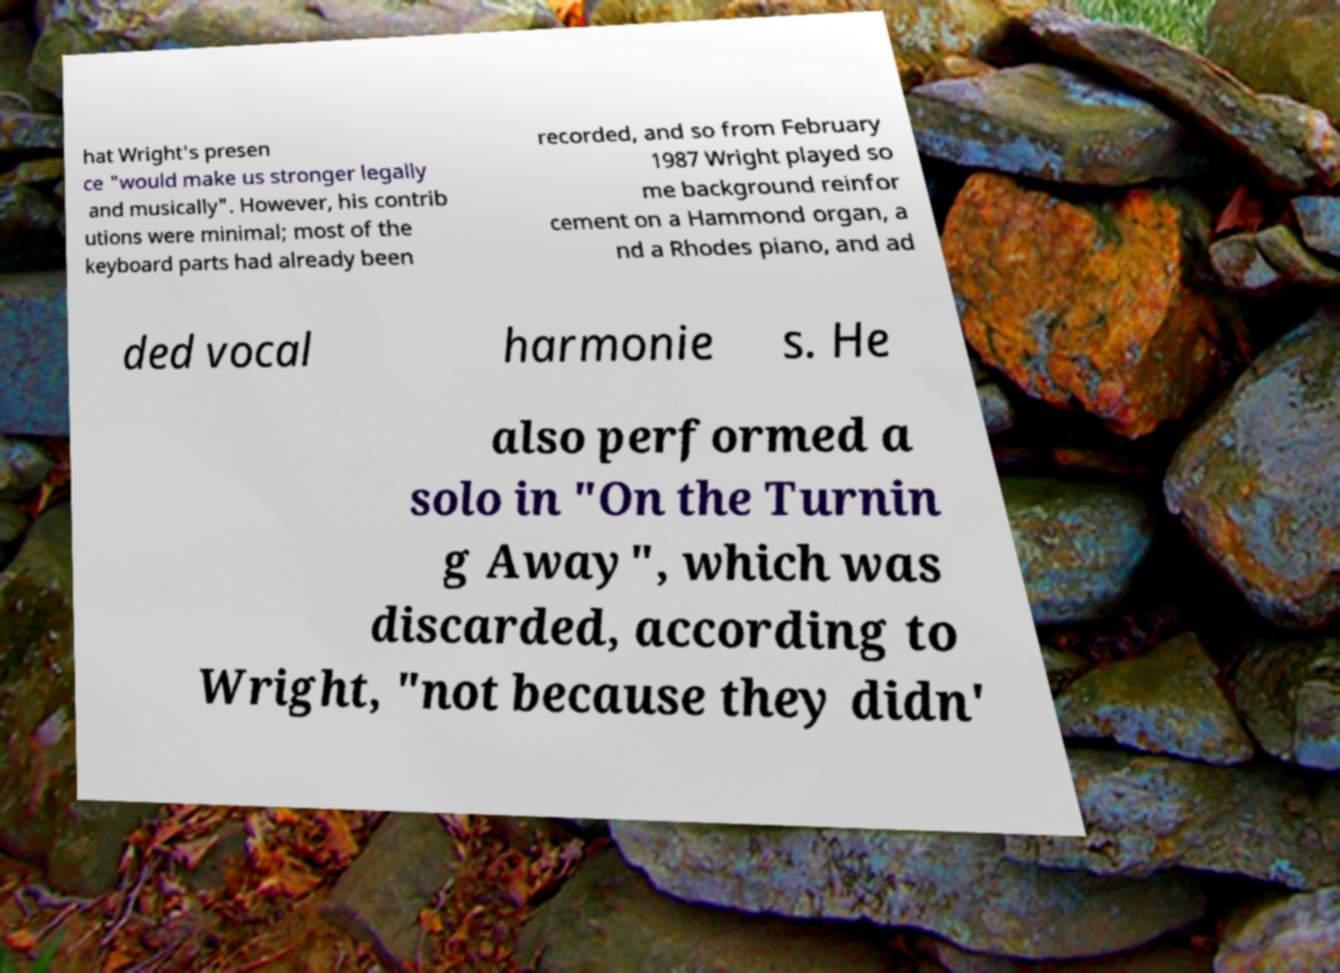For documentation purposes, I need the text within this image transcribed. Could you provide that? hat Wright's presen ce "would make us stronger legally and musically". However, his contrib utions were minimal; most of the keyboard parts had already been recorded, and so from February 1987 Wright played so me background reinfor cement on a Hammond organ, a nd a Rhodes piano, and ad ded vocal harmonie s. He also performed a solo in "On the Turnin g Away", which was discarded, according to Wright, "not because they didn' 